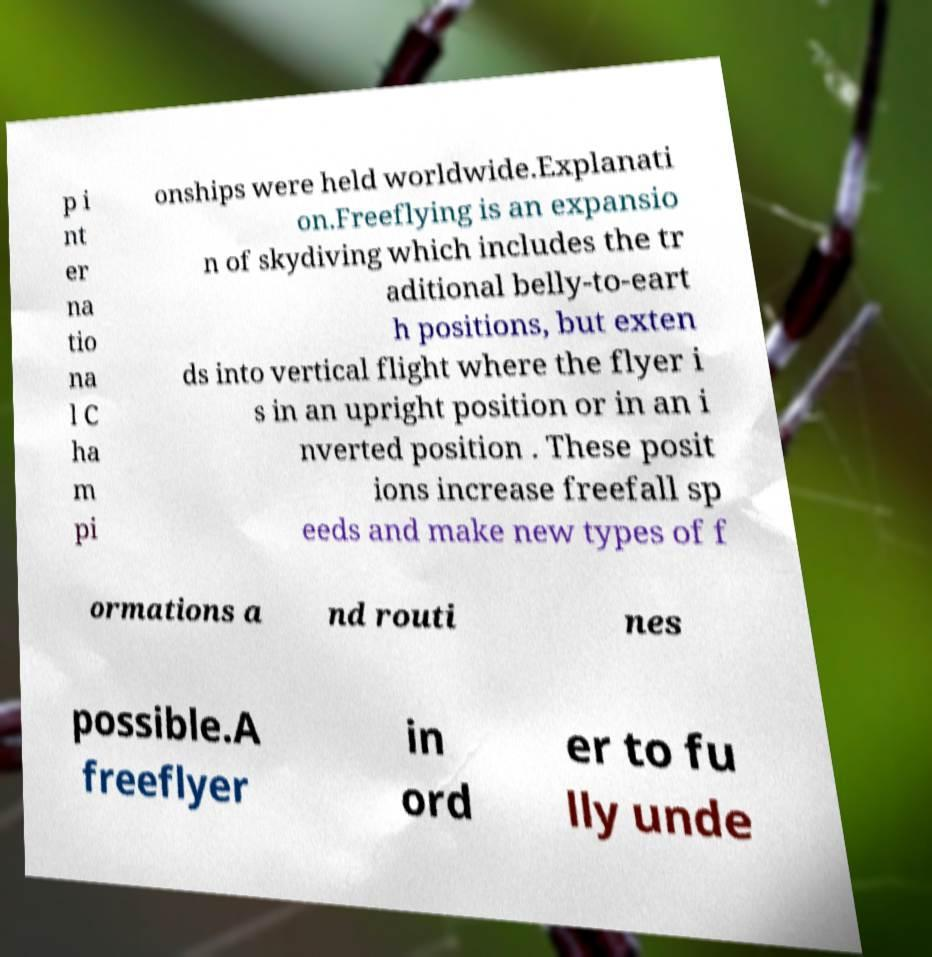There's text embedded in this image that I need extracted. Can you transcribe it verbatim? p i nt er na tio na l C ha m pi onships were held worldwide.Explanati on.Freeflying is an expansio n of skydiving which includes the tr aditional belly-to-eart h positions, but exten ds into vertical flight where the flyer i s in an upright position or in an i nverted position . These posit ions increase freefall sp eeds and make new types of f ormations a nd routi nes possible.A freeflyer in ord er to fu lly unde 